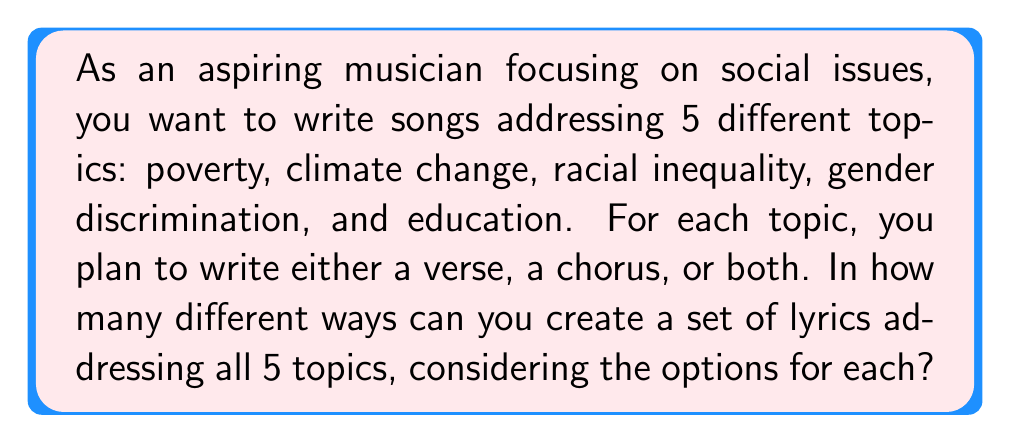What is the answer to this math problem? Let's approach this step-by-step:

1) For each topic, we have three options:
   - Write only a verse
   - Write only a chorus
   - Write both a verse and a chorus

2) This means for each topic, we have 3 choices.

3) We need to make this choice for all 5 topics independently.

4) When we have a series of independent choices, we multiply the number of options for each choice.

5) Therefore, we can use the multiplication principle:

   $$ \text{Total combinations} = 3 \times 3 \times 3 \times 3 \times 3 = 3^5 $$

6) Let's calculate this:

   $$ 3^5 = 3 \times 3 \times 3 \times 3 \times 3 = 243 $$

Thus, there are 243 different ways to create a set of lyrics addressing all 5 social issues, considering the options for each topic.
Answer: $243$ 